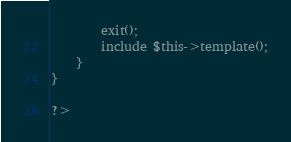Convert code to text. <code><loc_0><loc_0><loc_500><loc_500><_PHP_>		exit();
		include $this->template();
	}
}

?>
</code> 